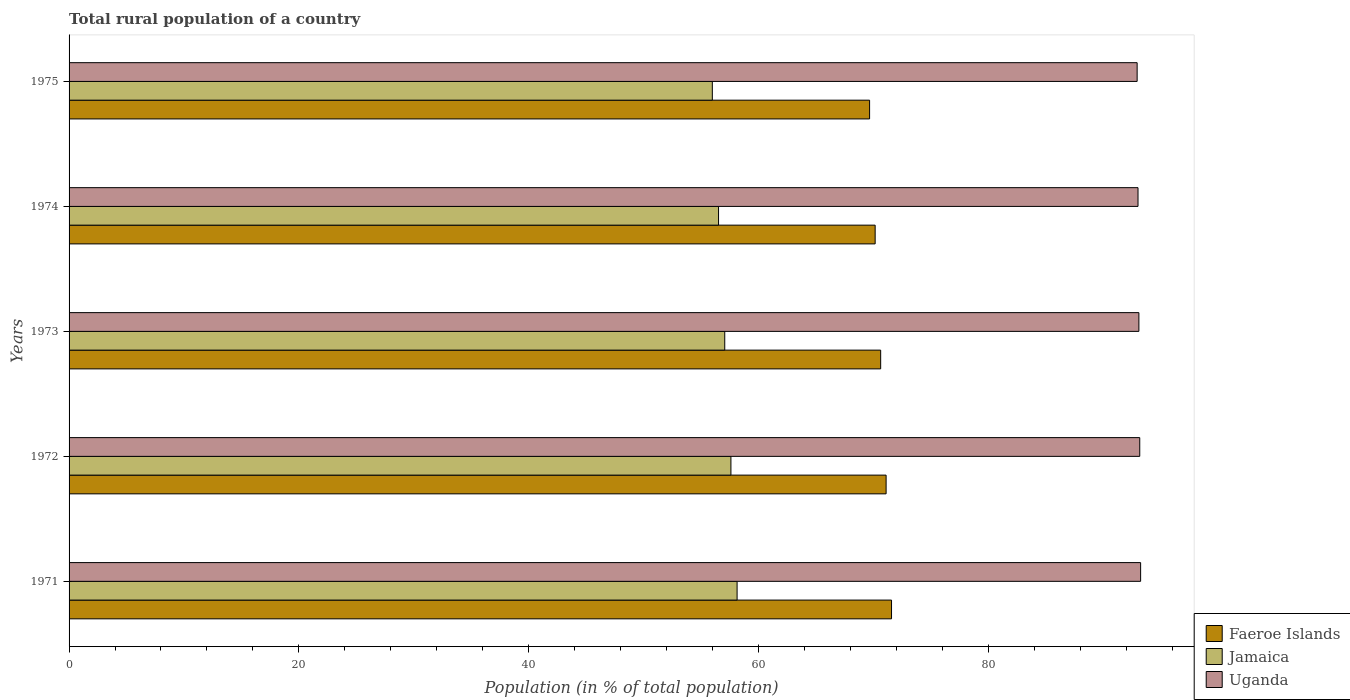How many groups of bars are there?
Your answer should be compact. 5. Are the number of bars on each tick of the Y-axis equal?
Offer a very short reply. Yes. What is the label of the 1st group of bars from the top?
Keep it short and to the point. 1975. In how many cases, is the number of bars for a given year not equal to the number of legend labels?
Provide a succinct answer. 0. What is the rural population in Faeroe Islands in 1973?
Provide a succinct answer. 70.64. Across all years, what is the maximum rural population in Faeroe Islands?
Provide a short and direct response. 71.58. Across all years, what is the minimum rural population in Jamaica?
Ensure brevity in your answer.  55.99. In which year was the rural population in Faeroe Islands minimum?
Make the answer very short. 1975. What is the total rural population in Faeroe Islands in the graph?
Keep it short and to the point. 353.16. What is the difference between the rural population in Jamaica in 1971 and that in 1973?
Your answer should be compact. 1.08. What is the difference between the rural population in Uganda in 1971 and the rural population in Jamaica in 1975?
Provide a short and direct response. 37.28. What is the average rural population in Faeroe Islands per year?
Keep it short and to the point. 70.63. In the year 1971, what is the difference between the rural population in Faeroe Islands and rural population in Uganda?
Your answer should be very brief. -21.68. What is the ratio of the rural population in Faeroe Islands in 1971 to that in 1972?
Provide a succinct answer. 1.01. What is the difference between the highest and the second highest rural population in Uganda?
Your answer should be very brief. 0.08. What is the difference between the highest and the lowest rural population in Uganda?
Offer a terse response. 0.3. In how many years, is the rural population in Faeroe Islands greater than the average rural population in Faeroe Islands taken over all years?
Your answer should be very brief. 3. Is the sum of the rural population in Faeroe Islands in 1972 and 1975 greater than the maximum rural population in Jamaica across all years?
Make the answer very short. Yes. What does the 3rd bar from the top in 1971 represents?
Offer a terse response. Faeroe Islands. What does the 2nd bar from the bottom in 1975 represents?
Make the answer very short. Jamaica. Is it the case that in every year, the sum of the rural population in Uganda and rural population in Jamaica is greater than the rural population in Faeroe Islands?
Provide a short and direct response. Yes. How many bars are there?
Offer a terse response. 15. Are all the bars in the graph horizontal?
Offer a very short reply. Yes. How many years are there in the graph?
Ensure brevity in your answer.  5. Does the graph contain grids?
Your answer should be compact. No. Where does the legend appear in the graph?
Provide a short and direct response. Bottom right. How many legend labels are there?
Offer a terse response. 3. How are the legend labels stacked?
Make the answer very short. Vertical. What is the title of the graph?
Keep it short and to the point. Total rural population of a country. Does "Cameroon" appear as one of the legend labels in the graph?
Make the answer very short. No. What is the label or title of the X-axis?
Keep it short and to the point. Population (in % of total population). What is the label or title of the Y-axis?
Ensure brevity in your answer.  Years. What is the Population (in % of total population) in Faeroe Islands in 1971?
Make the answer very short. 71.58. What is the Population (in % of total population) in Jamaica in 1971?
Offer a terse response. 58.14. What is the Population (in % of total population) in Uganda in 1971?
Provide a short and direct response. 93.26. What is the Population (in % of total population) in Faeroe Islands in 1972?
Your answer should be compact. 71.11. What is the Population (in % of total population) of Jamaica in 1972?
Offer a very short reply. 57.6. What is the Population (in % of total population) of Uganda in 1972?
Ensure brevity in your answer.  93.19. What is the Population (in % of total population) in Faeroe Islands in 1973?
Your answer should be compact. 70.64. What is the Population (in % of total population) in Jamaica in 1973?
Your answer should be very brief. 57.07. What is the Population (in % of total population) in Uganda in 1973?
Your answer should be compact. 93.11. What is the Population (in % of total population) of Faeroe Islands in 1974?
Make the answer very short. 70.16. What is the Population (in % of total population) of Jamaica in 1974?
Your answer should be compact. 56.53. What is the Population (in % of total population) in Uganda in 1974?
Offer a terse response. 93.04. What is the Population (in % of total population) in Faeroe Islands in 1975?
Offer a terse response. 69.67. What is the Population (in % of total population) of Jamaica in 1975?
Ensure brevity in your answer.  55.99. What is the Population (in % of total population) of Uganda in 1975?
Provide a succinct answer. 92.96. Across all years, what is the maximum Population (in % of total population) in Faeroe Islands?
Your answer should be very brief. 71.58. Across all years, what is the maximum Population (in % of total population) in Jamaica?
Offer a very short reply. 58.14. Across all years, what is the maximum Population (in % of total population) of Uganda?
Your response must be concise. 93.26. Across all years, what is the minimum Population (in % of total population) of Faeroe Islands?
Your response must be concise. 69.67. Across all years, what is the minimum Population (in % of total population) in Jamaica?
Ensure brevity in your answer.  55.99. Across all years, what is the minimum Population (in % of total population) in Uganda?
Ensure brevity in your answer.  92.96. What is the total Population (in % of total population) in Faeroe Islands in the graph?
Keep it short and to the point. 353.17. What is the total Population (in % of total population) of Jamaica in the graph?
Keep it short and to the point. 285.33. What is the total Population (in % of total population) in Uganda in the graph?
Give a very brief answer. 465.56. What is the difference between the Population (in % of total population) of Faeroe Islands in 1971 and that in 1972?
Offer a terse response. 0.47. What is the difference between the Population (in % of total population) of Jamaica in 1971 and that in 1972?
Keep it short and to the point. 0.54. What is the difference between the Population (in % of total population) in Uganda in 1971 and that in 1972?
Your answer should be very brief. 0.07. What is the difference between the Population (in % of total population) of Faeroe Islands in 1971 and that in 1973?
Your response must be concise. 0.94. What is the difference between the Population (in % of total population) in Jamaica in 1971 and that in 1973?
Your answer should be compact. 1.07. What is the difference between the Population (in % of total population) of Uganda in 1971 and that in 1973?
Your response must be concise. 0.15. What is the difference between the Population (in % of total population) in Faeroe Islands in 1971 and that in 1974?
Provide a succinct answer. 1.43. What is the difference between the Population (in % of total population) of Jamaica in 1971 and that in 1974?
Your response must be concise. 1.61. What is the difference between the Population (in % of total population) in Uganda in 1971 and that in 1974?
Provide a succinct answer. 0.23. What is the difference between the Population (in % of total population) in Faeroe Islands in 1971 and that in 1975?
Your answer should be compact. 1.91. What is the difference between the Population (in % of total population) of Jamaica in 1971 and that in 1975?
Keep it short and to the point. 2.15. What is the difference between the Population (in % of total population) of Uganda in 1971 and that in 1975?
Your response must be concise. 0.3. What is the difference between the Population (in % of total population) in Faeroe Islands in 1972 and that in 1973?
Provide a succinct answer. 0.47. What is the difference between the Population (in % of total population) in Jamaica in 1972 and that in 1973?
Keep it short and to the point. 0.54. What is the difference between the Population (in % of total population) in Uganda in 1972 and that in 1973?
Ensure brevity in your answer.  0.07. What is the difference between the Population (in % of total population) of Faeroe Islands in 1972 and that in 1974?
Provide a short and direct response. 0.95. What is the difference between the Population (in % of total population) in Jamaica in 1972 and that in 1974?
Make the answer very short. 1.08. What is the difference between the Population (in % of total population) in Uganda in 1972 and that in 1974?
Provide a short and direct response. 0.15. What is the difference between the Population (in % of total population) in Faeroe Islands in 1972 and that in 1975?
Your response must be concise. 1.44. What is the difference between the Population (in % of total population) in Jamaica in 1972 and that in 1975?
Offer a terse response. 1.62. What is the difference between the Population (in % of total population) of Uganda in 1972 and that in 1975?
Make the answer very short. 0.23. What is the difference between the Population (in % of total population) in Faeroe Islands in 1973 and that in 1974?
Your response must be concise. 0.48. What is the difference between the Population (in % of total population) in Jamaica in 1973 and that in 1974?
Your answer should be compact. 0.54. What is the difference between the Population (in % of total population) in Uganda in 1973 and that in 1974?
Provide a succinct answer. 0.08. What is the difference between the Population (in % of total population) in Jamaica in 1973 and that in 1975?
Keep it short and to the point. 1.08. What is the difference between the Population (in % of total population) of Uganda in 1973 and that in 1975?
Offer a very short reply. 0.15. What is the difference between the Population (in % of total population) in Faeroe Islands in 1974 and that in 1975?
Your answer should be very brief. 0.48. What is the difference between the Population (in % of total population) of Jamaica in 1974 and that in 1975?
Your answer should be very brief. 0.54. What is the difference between the Population (in % of total population) of Uganda in 1974 and that in 1975?
Make the answer very short. 0.08. What is the difference between the Population (in % of total population) of Faeroe Islands in 1971 and the Population (in % of total population) of Jamaica in 1972?
Offer a terse response. 13.98. What is the difference between the Population (in % of total population) of Faeroe Islands in 1971 and the Population (in % of total population) of Uganda in 1972?
Provide a succinct answer. -21.61. What is the difference between the Population (in % of total population) in Jamaica in 1971 and the Population (in % of total population) in Uganda in 1972?
Your answer should be compact. -35.05. What is the difference between the Population (in % of total population) of Faeroe Islands in 1971 and the Population (in % of total population) of Jamaica in 1973?
Offer a terse response. 14.52. What is the difference between the Population (in % of total population) of Faeroe Islands in 1971 and the Population (in % of total population) of Uganda in 1973?
Offer a terse response. -21.53. What is the difference between the Population (in % of total population) of Jamaica in 1971 and the Population (in % of total population) of Uganda in 1973?
Offer a very short reply. -34.97. What is the difference between the Population (in % of total population) of Faeroe Islands in 1971 and the Population (in % of total population) of Jamaica in 1974?
Your answer should be compact. 15.05. What is the difference between the Population (in % of total population) of Faeroe Islands in 1971 and the Population (in % of total population) of Uganda in 1974?
Your answer should be very brief. -21.45. What is the difference between the Population (in % of total population) of Jamaica in 1971 and the Population (in % of total population) of Uganda in 1974?
Keep it short and to the point. -34.9. What is the difference between the Population (in % of total population) in Faeroe Islands in 1971 and the Population (in % of total population) in Jamaica in 1975?
Provide a short and direct response. 15.6. What is the difference between the Population (in % of total population) in Faeroe Islands in 1971 and the Population (in % of total population) in Uganda in 1975?
Your answer should be very brief. -21.38. What is the difference between the Population (in % of total population) of Jamaica in 1971 and the Population (in % of total population) of Uganda in 1975?
Provide a succinct answer. -34.82. What is the difference between the Population (in % of total population) in Faeroe Islands in 1972 and the Population (in % of total population) in Jamaica in 1973?
Give a very brief answer. 14.04. What is the difference between the Population (in % of total population) of Faeroe Islands in 1972 and the Population (in % of total population) of Uganda in 1973?
Your answer should be very brief. -22. What is the difference between the Population (in % of total population) in Jamaica in 1972 and the Population (in % of total population) in Uganda in 1973?
Provide a short and direct response. -35.51. What is the difference between the Population (in % of total population) in Faeroe Islands in 1972 and the Population (in % of total population) in Jamaica in 1974?
Make the answer very short. 14.58. What is the difference between the Population (in % of total population) in Faeroe Islands in 1972 and the Population (in % of total population) in Uganda in 1974?
Provide a succinct answer. -21.93. What is the difference between the Population (in % of total population) in Jamaica in 1972 and the Population (in % of total population) in Uganda in 1974?
Provide a short and direct response. -35.43. What is the difference between the Population (in % of total population) in Faeroe Islands in 1972 and the Population (in % of total population) in Jamaica in 1975?
Ensure brevity in your answer.  15.12. What is the difference between the Population (in % of total population) of Faeroe Islands in 1972 and the Population (in % of total population) of Uganda in 1975?
Keep it short and to the point. -21.85. What is the difference between the Population (in % of total population) in Jamaica in 1972 and the Population (in % of total population) in Uganda in 1975?
Provide a short and direct response. -35.35. What is the difference between the Population (in % of total population) of Faeroe Islands in 1973 and the Population (in % of total population) of Jamaica in 1974?
Offer a terse response. 14.11. What is the difference between the Population (in % of total population) of Faeroe Islands in 1973 and the Population (in % of total population) of Uganda in 1974?
Give a very brief answer. -22.4. What is the difference between the Population (in % of total population) in Jamaica in 1973 and the Population (in % of total population) in Uganda in 1974?
Ensure brevity in your answer.  -35.97. What is the difference between the Population (in % of total population) in Faeroe Islands in 1973 and the Population (in % of total population) in Jamaica in 1975?
Offer a very short reply. 14.65. What is the difference between the Population (in % of total population) in Faeroe Islands in 1973 and the Population (in % of total population) in Uganda in 1975?
Make the answer very short. -22.32. What is the difference between the Population (in % of total population) of Jamaica in 1973 and the Population (in % of total population) of Uganda in 1975?
Your response must be concise. -35.89. What is the difference between the Population (in % of total population) in Faeroe Islands in 1974 and the Population (in % of total population) in Jamaica in 1975?
Make the answer very short. 14.17. What is the difference between the Population (in % of total population) in Faeroe Islands in 1974 and the Population (in % of total population) in Uganda in 1975?
Your answer should be very brief. -22.8. What is the difference between the Population (in % of total population) of Jamaica in 1974 and the Population (in % of total population) of Uganda in 1975?
Make the answer very short. -36.43. What is the average Population (in % of total population) of Faeroe Islands per year?
Give a very brief answer. 70.63. What is the average Population (in % of total population) in Jamaica per year?
Your answer should be compact. 57.07. What is the average Population (in % of total population) in Uganda per year?
Offer a very short reply. 93.11. In the year 1971, what is the difference between the Population (in % of total population) in Faeroe Islands and Population (in % of total population) in Jamaica?
Keep it short and to the point. 13.44. In the year 1971, what is the difference between the Population (in % of total population) in Faeroe Islands and Population (in % of total population) in Uganda?
Provide a short and direct response. -21.68. In the year 1971, what is the difference between the Population (in % of total population) in Jamaica and Population (in % of total population) in Uganda?
Make the answer very short. -35.12. In the year 1972, what is the difference between the Population (in % of total population) of Faeroe Islands and Population (in % of total population) of Jamaica?
Offer a terse response. 13.51. In the year 1972, what is the difference between the Population (in % of total population) in Faeroe Islands and Population (in % of total population) in Uganda?
Offer a terse response. -22.08. In the year 1972, what is the difference between the Population (in % of total population) of Jamaica and Population (in % of total population) of Uganda?
Ensure brevity in your answer.  -35.58. In the year 1973, what is the difference between the Population (in % of total population) in Faeroe Islands and Population (in % of total population) in Jamaica?
Ensure brevity in your answer.  13.57. In the year 1973, what is the difference between the Population (in % of total population) of Faeroe Islands and Population (in % of total population) of Uganda?
Give a very brief answer. -22.48. In the year 1973, what is the difference between the Population (in % of total population) of Jamaica and Population (in % of total population) of Uganda?
Your answer should be compact. -36.05. In the year 1974, what is the difference between the Population (in % of total population) of Faeroe Islands and Population (in % of total population) of Jamaica?
Offer a very short reply. 13.63. In the year 1974, what is the difference between the Population (in % of total population) in Faeroe Islands and Population (in % of total population) in Uganda?
Your answer should be very brief. -22.88. In the year 1974, what is the difference between the Population (in % of total population) in Jamaica and Population (in % of total population) in Uganda?
Your answer should be compact. -36.51. In the year 1975, what is the difference between the Population (in % of total population) of Faeroe Islands and Population (in % of total population) of Jamaica?
Make the answer very short. 13.69. In the year 1975, what is the difference between the Population (in % of total population) of Faeroe Islands and Population (in % of total population) of Uganda?
Make the answer very short. -23.29. In the year 1975, what is the difference between the Population (in % of total population) of Jamaica and Population (in % of total population) of Uganda?
Ensure brevity in your answer.  -36.97. What is the ratio of the Population (in % of total population) of Faeroe Islands in 1971 to that in 1972?
Ensure brevity in your answer.  1.01. What is the ratio of the Population (in % of total population) in Jamaica in 1971 to that in 1972?
Offer a very short reply. 1.01. What is the ratio of the Population (in % of total population) of Uganda in 1971 to that in 1972?
Your answer should be very brief. 1. What is the ratio of the Population (in % of total population) in Faeroe Islands in 1971 to that in 1973?
Offer a terse response. 1.01. What is the ratio of the Population (in % of total population) in Jamaica in 1971 to that in 1973?
Your answer should be very brief. 1.02. What is the ratio of the Population (in % of total population) in Uganda in 1971 to that in 1973?
Keep it short and to the point. 1. What is the ratio of the Population (in % of total population) in Faeroe Islands in 1971 to that in 1974?
Offer a very short reply. 1.02. What is the ratio of the Population (in % of total population) of Jamaica in 1971 to that in 1974?
Provide a succinct answer. 1.03. What is the ratio of the Population (in % of total population) in Uganda in 1971 to that in 1974?
Provide a succinct answer. 1. What is the ratio of the Population (in % of total population) of Faeroe Islands in 1971 to that in 1975?
Keep it short and to the point. 1.03. What is the ratio of the Population (in % of total population) in Jamaica in 1971 to that in 1975?
Ensure brevity in your answer.  1.04. What is the ratio of the Population (in % of total population) of Uganda in 1971 to that in 1975?
Offer a terse response. 1. What is the ratio of the Population (in % of total population) of Jamaica in 1972 to that in 1973?
Ensure brevity in your answer.  1.01. What is the ratio of the Population (in % of total population) in Faeroe Islands in 1972 to that in 1974?
Offer a terse response. 1.01. What is the ratio of the Population (in % of total population) of Jamaica in 1972 to that in 1974?
Provide a succinct answer. 1.02. What is the ratio of the Population (in % of total population) in Uganda in 1972 to that in 1974?
Your answer should be compact. 1. What is the ratio of the Population (in % of total population) in Faeroe Islands in 1972 to that in 1975?
Keep it short and to the point. 1.02. What is the ratio of the Population (in % of total population) of Jamaica in 1972 to that in 1975?
Your answer should be very brief. 1.03. What is the ratio of the Population (in % of total population) of Faeroe Islands in 1973 to that in 1974?
Offer a very short reply. 1.01. What is the ratio of the Population (in % of total population) in Jamaica in 1973 to that in 1974?
Offer a very short reply. 1.01. What is the ratio of the Population (in % of total population) in Faeroe Islands in 1973 to that in 1975?
Provide a short and direct response. 1.01. What is the ratio of the Population (in % of total population) in Jamaica in 1973 to that in 1975?
Your answer should be very brief. 1.02. What is the ratio of the Population (in % of total population) of Jamaica in 1974 to that in 1975?
Provide a short and direct response. 1.01. What is the ratio of the Population (in % of total population) of Uganda in 1974 to that in 1975?
Make the answer very short. 1. What is the difference between the highest and the second highest Population (in % of total population) in Faeroe Islands?
Keep it short and to the point. 0.47. What is the difference between the highest and the second highest Population (in % of total population) in Jamaica?
Offer a terse response. 0.54. What is the difference between the highest and the second highest Population (in % of total population) in Uganda?
Ensure brevity in your answer.  0.07. What is the difference between the highest and the lowest Population (in % of total population) of Faeroe Islands?
Your response must be concise. 1.91. What is the difference between the highest and the lowest Population (in % of total population) in Jamaica?
Give a very brief answer. 2.15. What is the difference between the highest and the lowest Population (in % of total population) in Uganda?
Offer a terse response. 0.3. 